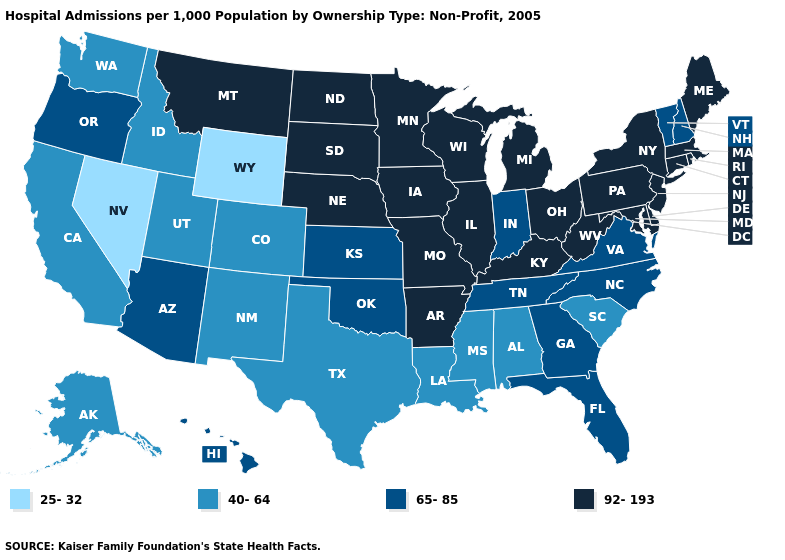Name the states that have a value in the range 92-193?
Be succinct. Arkansas, Connecticut, Delaware, Illinois, Iowa, Kentucky, Maine, Maryland, Massachusetts, Michigan, Minnesota, Missouri, Montana, Nebraska, New Jersey, New York, North Dakota, Ohio, Pennsylvania, Rhode Island, South Dakota, West Virginia, Wisconsin. Does Alabama have a higher value than Oregon?
Write a very short answer. No. Does the map have missing data?
Be succinct. No. Among the states that border Illinois , does Indiana have the highest value?
Write a very short answer. No. What is the value of Alabama?
Be succinct. 40-64. What is the value of Montana?
Keep it brief. 92-193. What is the lowest value in states that border Michigan?
Short answer required. 65-85. What is the lowest value in the West?
Answer briefly. 25-32. Name the states that have a value in the range 40-64?
Be succinct. Alabama, Alaska, California, Colorado, Idaho, Louisiana, Mississippi, New Mexico, South Carolina, Texas, Utah, Washington. Does Tennessee have a higher value than South Carolina?
Short answer required. Yes. What is the value of Texas?
Short answer required. 40-64. What is the lowest value in the Northeast?
Keep it brief. 65-85. Name the states that have a value in the range 40-64?
Write a very short answer. Alabama, Alaska, California, Colorado, Idaho, Louisiana, Mississippi, New Mexico, South Carolina, Texas, Utah, Washington. Does the map have missing data?
Short answer required. No. What is the value of Arizona?
Quick response, please. 65-85. 